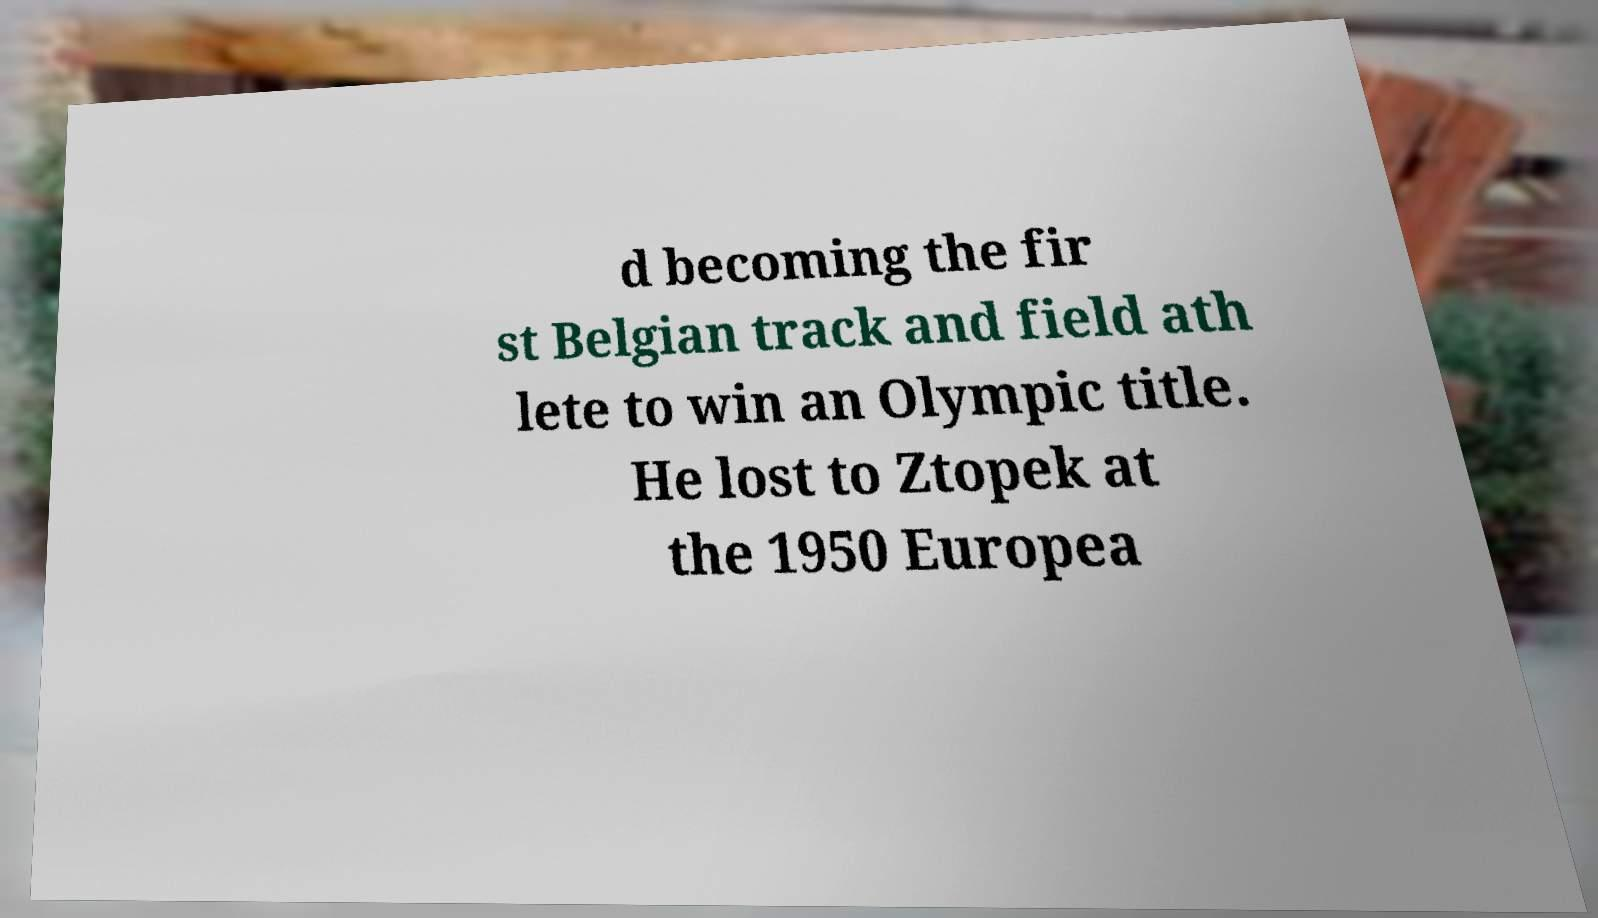Please identify and transcribe the text found in this image. d becoming the fir st Belgian track and field ath lete to win an Olympic title. He lost to Ztopek at the 1950 Europea 